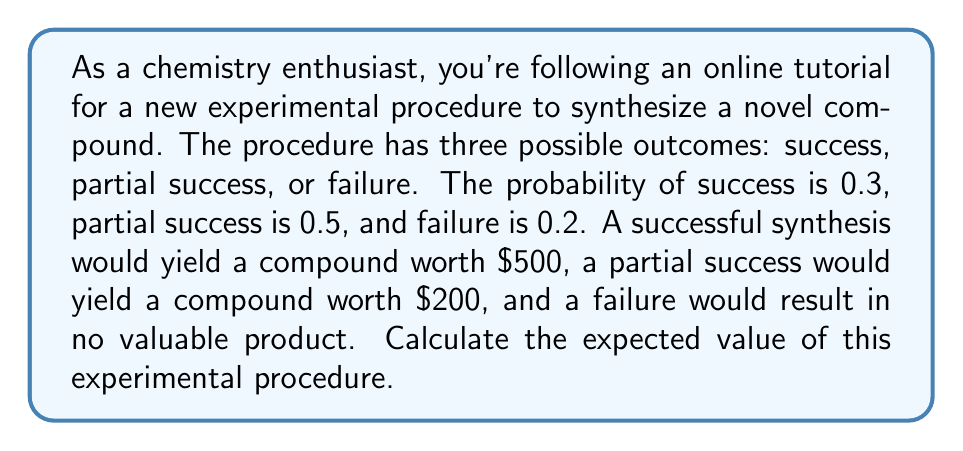Solve this math problem. To calculate the expected value of this experimental procedure, we need to use the concept of expected value from decision theory. The expected value is the sum of each possible outcome multiplied by its probability.

Let's define our variables:
$p_s$ = probability of success = 0.3
$p_p$ = probability of partial success = 0.5
$p_f$ = probability of failure = 0.2
$v_s$ = value of success = $500
$v_p$ = value of partial success = $200
$v_f$ = value of failure = $0

The formula for expected value (EV) is:

$$ EV = (p_s \times v_s) + (p_p \times v_p) + (p_f \times v_f) $$

Now, let's substitute our values:

$$ EV = (0.3 \times \$500) + (0.5 \times \$200) + (0.2 \times \$0) $$

Let's calculate each term:
1. $(0.3 \times \$500) = \$150$
2. $(0.5 \times \$200) = \$100$
3. $(0.2 \times \$0) = \$0$

Now, sum up all terms:

$$ EV = \$150 + \$100 + \$0 = \$250 $$

Therefore, the expected value of this experimental procedure is $250.
Answer: $250 